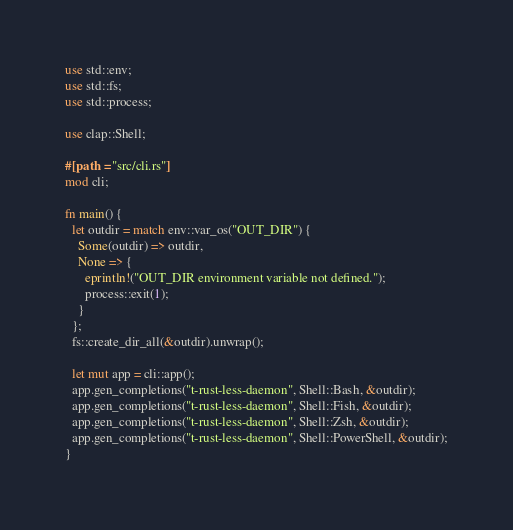Convert code to text. <code><loc_0><loc_0><loc_500><loc_500><_Rust_>use std::env;
use std::fs;
use std::process;

use clap::Shell;

#[path = "src/cli.rs"]
mod cli;

fn main() {
  let outdir = match env::var_os("OUT_DIR") {
    Some(outdir) => outdir,
    None => {
      eprintln!("OUT_DIR environment variable not defined.");
      process::exit(1);
    }
  };
  fs::create_dir_all(&outdir).unwrap();

  let mut app = cli::app();
  app.gen_completions("t-rust-less-daemon", Shell::Bash, &outdir);
  app.gen_completions("t-rust-less-daemon", Shell::Fish, &outdir);
  app.gen_completions("t-rust-less-daemon", Shell::Zsh, &outdir);
  app.gen_completions("t-rust-less-daemon", Shell::PowerShell, &outdir);
}
</code> 